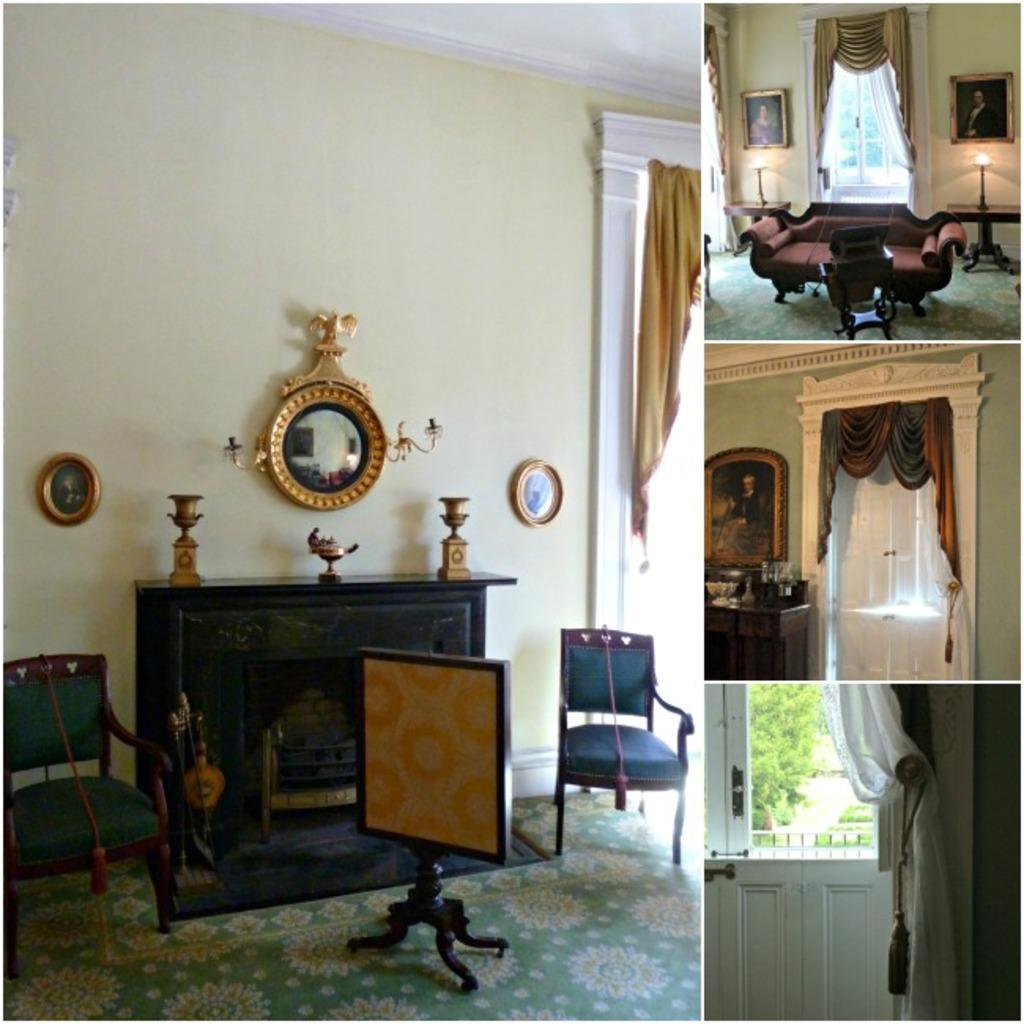In one or two sentences, can you explain what this image depicts? This is a collage image. In this image I can see four pictures. In the four pictures, I can see the inside view of a room. In the left side image there is a table, chairs and few frames are attached to the wall. In the right side images, I can see the curtains to the windows, couch, frames to the walls and lamps. 